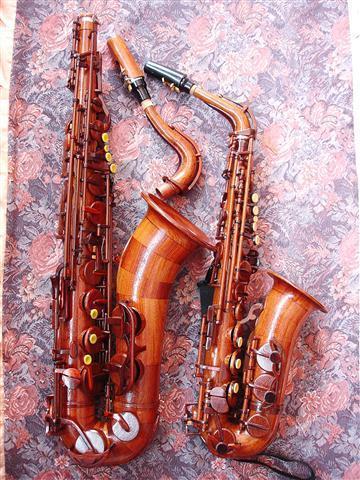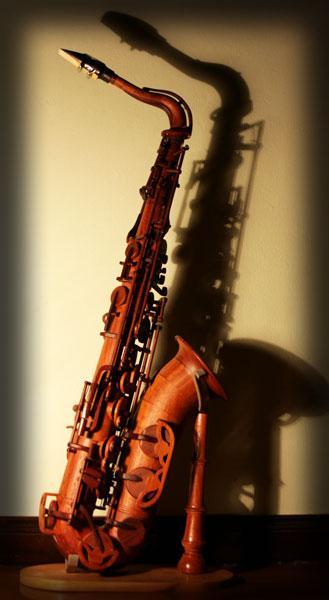The first image is the image on the left, the second image is the image on the right. Considering the images on both sides, is "An image shows a wooden bamboo on a stand with light behind it creating deep shadow." valid? Answer yes or no. Yes. The first image is the image on the left, the second image is the image on the right. Examine the images to the left and right. Is the description "The saxophone in one of the images is on a stand." accurate? Answer yes or no. Yes. 